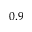Convert formula to latex. <formula><loc_0><loc_0><loc_500><loc_500>0 . 9</formula> 